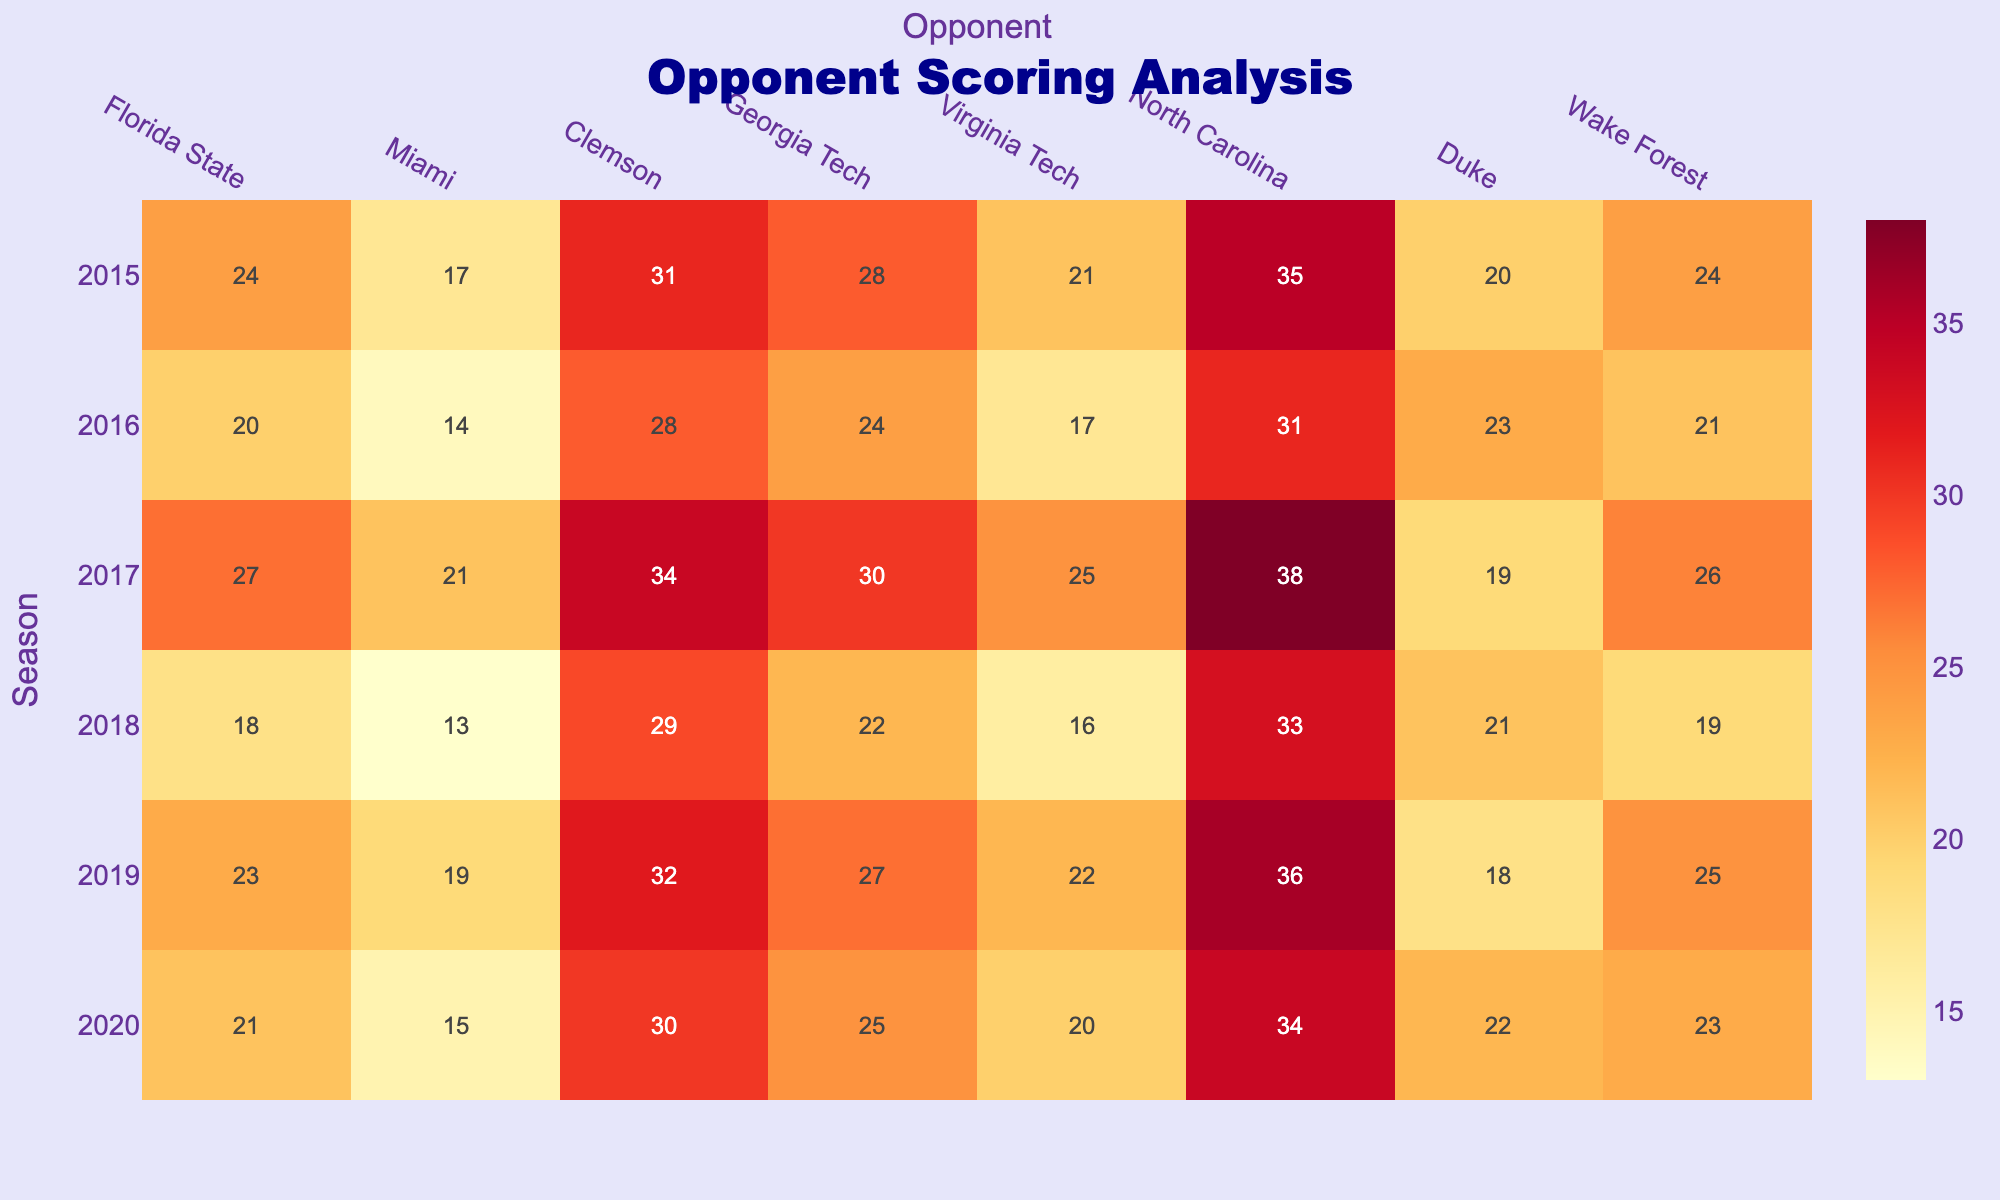What was the highest opponent score against Maurice Carnell's team in the 2017 season? Looking at the 2017 row in the table, the highest opponent score is 38 points from North Carolina.
Answer: 38 Which opponent did Maurice Carnell's team score the most against in the 2015 season? In the 2015 row, the highest score is 35 points against North Carolina.
Answer: North Carolina What is the average score that opponents achieved against Maurice Carnell's team in the 2018 season? The scores against Maurice Carnell's team in the 2018 season are: 18, 13, 29, 22, 16, 33, 21, 19. Summing these scores gives 18 + 13 + 29 + 22 + 16 + 33 + 21 + 19 = 201. There are 8 opponents, so the average is 201/8 = 25.125.
Answer: 25.125 Did Maurice Carnell's team ever allow an opponent to score less than 15 points? Reviewing all opponent scores from each season in the table, the lowest score allowed is 13 points to Miami in the 2018 season, which is less than 15.
Answer: Yes What is the difference between the highest and lowest scores allowed by Maurice Carnell's team in the 2016 season? For the 2016 season, the highest score allowed is 31 points (North Carolina) and the lowest is 14 points (Miami). The difference is 31 - 14 = 17 points.
Answer: 17 Was the total number of points scored by opponents in the 2019 season greater than in the 2015 season? The total points scored against Maurice Carnell's team in 2019 is 23 + 19 + 32 + 27 + 22 + 36 + 18 + 25 = 202. In 2015, the total points are 24 + 17 + 31 + 28 + 21 + 35 + 20 + 24 = 200. Thus, 202 is greater than 200.
Answer: Yes How many seasons had at least one opponent scoring 30 or more points against Maurice Carnell's team? From the table, the seasons where at least one opponent scored 30 or more points are 2015, 2017, 2019, and 2020. There are four seasons where this occurred.
Answer: 4 Which opponent had the lowest total score across all seasons shown in the table? Summing the scores for each opponent: Florida State (24+20+27+18+23+21=133), Miami (17+14+21+13+19+15=99), Clemson (31+28+34+29+32+30=184), Georgia Tech (28+24+30+22+27+25=156), Virginia Tech (21+17+25+16+22+20=121), North Carolina (35+31+38+33+36+34=207), Duke (20+23+19+21+18+22=123), Wake Forest (24+21+26+19+25+23=138). The lowest total is for Miami with 99 points.
Answer: Miami In which season did Maurice Carnell's team see the highest scoring opponent? Analyzing the table, the highest score is 38 points by North Carolina in the 2017 season.
Answer: 2017 What is the trend of opponent scoring across the seasons presented in the table? By comparing the seasons, one can observe fluctuations in scores, but an overall trend shows that 2017 had the highest scores while 2018 had relatively lower opponent scores. Thus, scoring varied distinctly over the seasons without a clear upward or downward trend overall.
Answer: Fluctuating scores, highest in 2017, lowest in 2018 